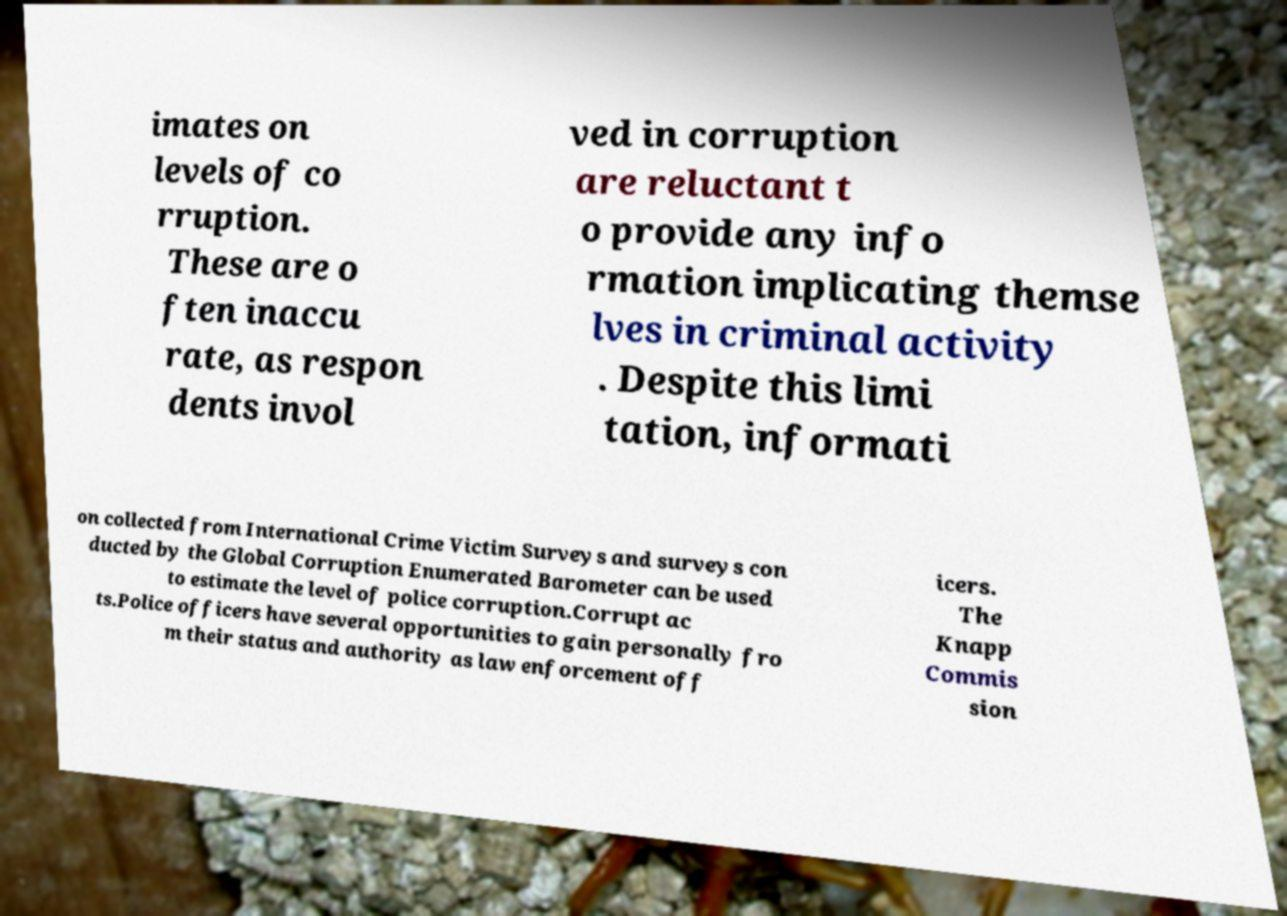Could you assist in decoding the text presented in this image and type it out clearly? imates on levels of co rruption. These are o ften inaccu rate, as respon dents invol ved in corruption are reluctant t o provide any info rmation implicating themse lves in criminal activity . Despite this limi tation, informati on collected from International Crime Victim Surveys and surveys con ducted by the Global Corruption Enumerated Barometer can be used to estimate the level of police corruption.Corrupt ac ts.Police officers have several opportunities to gain personally fro m their status and authority as law enforcement off icers. The Knapp Commis sion 